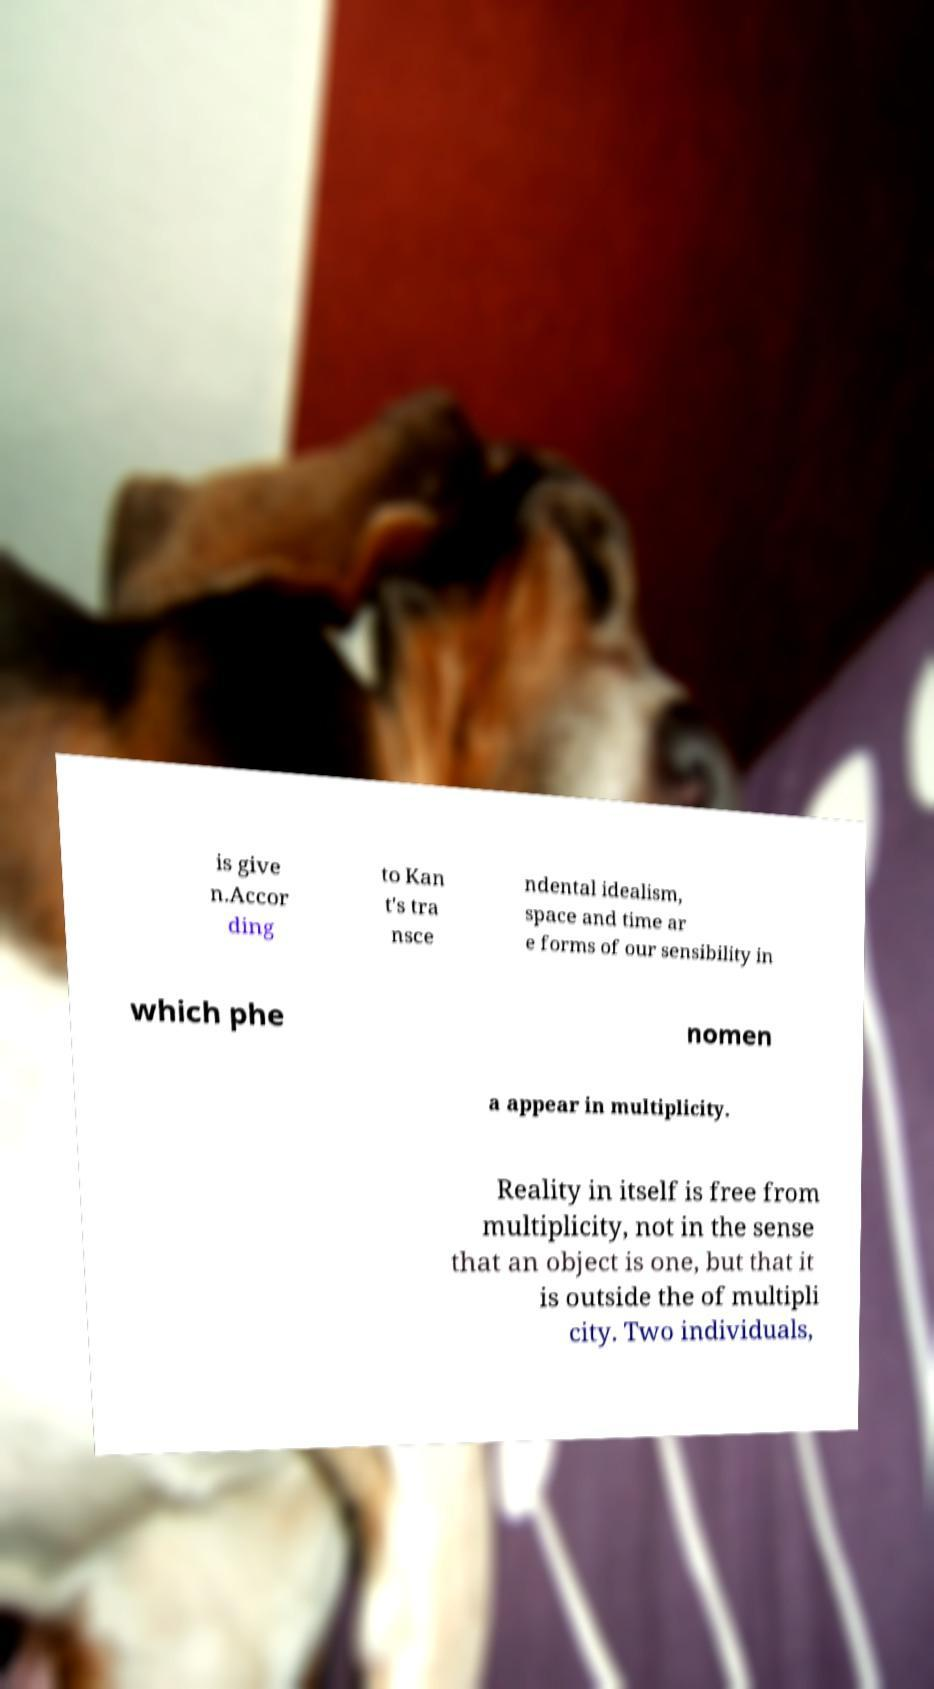I need the written content from this picture converted into text. Can you do that? is give n.Accor ding to Kan t's tra nsce ndental idealism, space and time ar e forms of our sensibility in which phe nomen a appear in multiplicity. Reality in itself is free from multiplicity, not in the sense that an object is one, but that it is outside the of multipli city. Two individuals, 